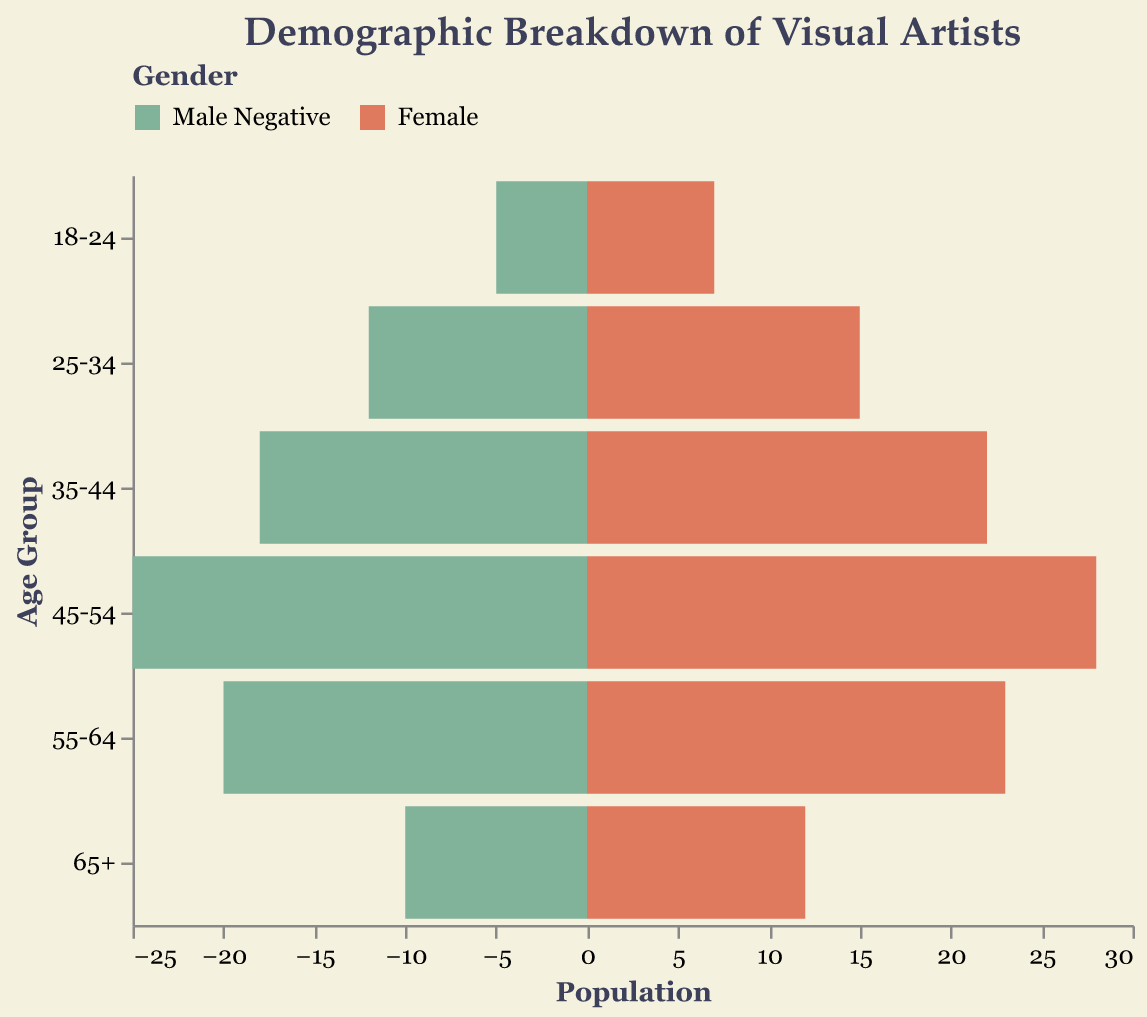What is the title of the plot? The title is provided at the top of the plot which is "Demographic Breakdown of Visual Artists".
Answer: Demographic Breakdown of Visual Artists What are the two genders represented in the chart? The chart uses different colors to represent genders, labeled in the legend as "Male Negative" and "Female".
Answer: Male Negative, Female Which age group has the highest number of female visual artists? From the plot, the age group 45-54 has the highest bar for females.
Answer: 45-54 How many males are there in the 35-44 age group? The data shows that for the 35-44 age group, there are 18 male visual artists.
Answer: 18 How many female visual artists are there in total across all age groups? Add the female counts for each age group: 7 + 15 + 22 + 28 + 23 + 12 = 107.
Answer: 107 What age group has the largest difference between the number of male and female visual artists? The differences for each age group are: 18-24: 2, 25-34: 3, 35-44: 4, 45-54: 3, 55-64: 3, 65+: 2. The 35-44 age group has the largest difference (4).
Answer: 35-44 Which age group has more male than female visual artists? In all age groups, the number of female visual artists is greater than that of males.
Answer: None What can you infer about the trend in the number of visual artists as the age increases? Both male and female numbers increase until the 45-54 age group and then decrease.
Answer: The number of visual artists increases until 45-54 and then declines What is the total population of visual artists in the 55-64 age group? Add the male and female counts: 20 (male) + 23 (female) = 43.
Answer: 43 In which age group is the gender disparity (difference) smallest? The differences for each age group are: 18-24: 2, 25-34: 3, 35-44: 4, 45-54: 3, 55-64: 3, 65+: 2. The smallest differences are in 18-24 and 65+ with a difference of 2 each.
Answer: 18-24, 65+ 